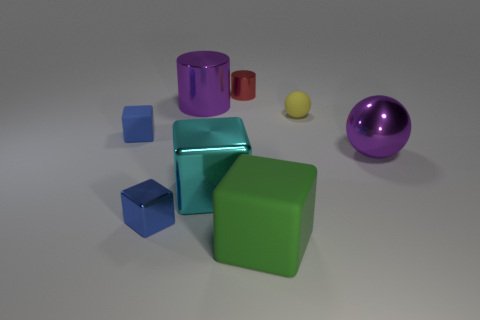Is the size of the rubber block on the left side of the red cylinder the same as the big cyan object?
Offer a very short reply. No. What number of yellow spheres are the same size as the green thing?
Offer a very short reply. 0. What is the size of the thing that is the same color as the big cylinder?
Your answer should be compact. Large. Does the large ball have the same color as the large rubber block?
Provide a succinct answer. No. The blue matte object is what shape?
Your answer should be very brief. Cube. Are there any metal blocks that have the same color as the big matte cube?
Your response must be concise. No. Is the number of cyan blocks in front of the big cyan shiny cube greater than the number of purple metal things?
Make the answer very short. No. There is a large rubber object; does it have the same shape as the metallic object that is to the right of the red thing?
Offer a terse response. No. Are there any tiny blue cubes?
Your answer should be compact. Yes. What number of small objects are either cyan metallic objects or purple matte objects?
Offer a terse response. 0. 